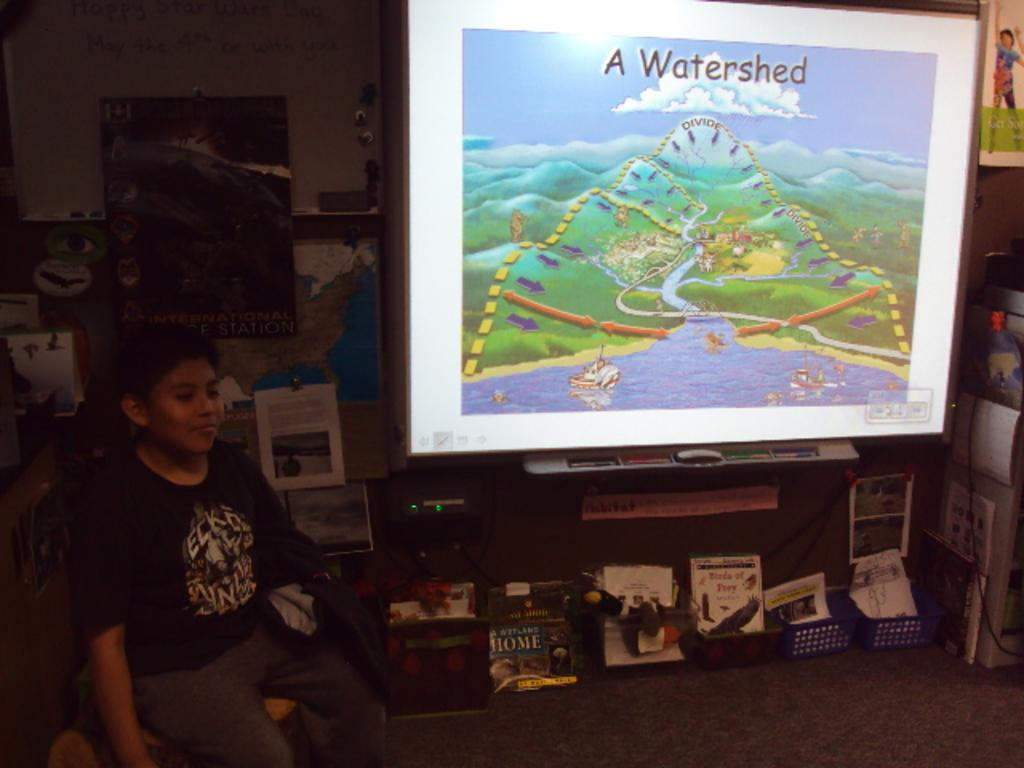What is the boy doing in the image? The boy is sitting on a chair in the image. What items can be seen on the table or nearby surfaces in the image? There are papers, toys, objects in trays, a screen, pens, and a map in the image. What type of flooring is visible in the image? There is a carpet in the image. Are there any decorative elements on the wall in the image? Yes, there are frames attached to the wall in the image. What type of vest is the lawyer wearing in the image? There is no lawyer or vest present in the image. What type of building is depicted in the image? The image does not show a building; it primarily features a boy sitting on a chair and various items on a table or nearby surfaces. 